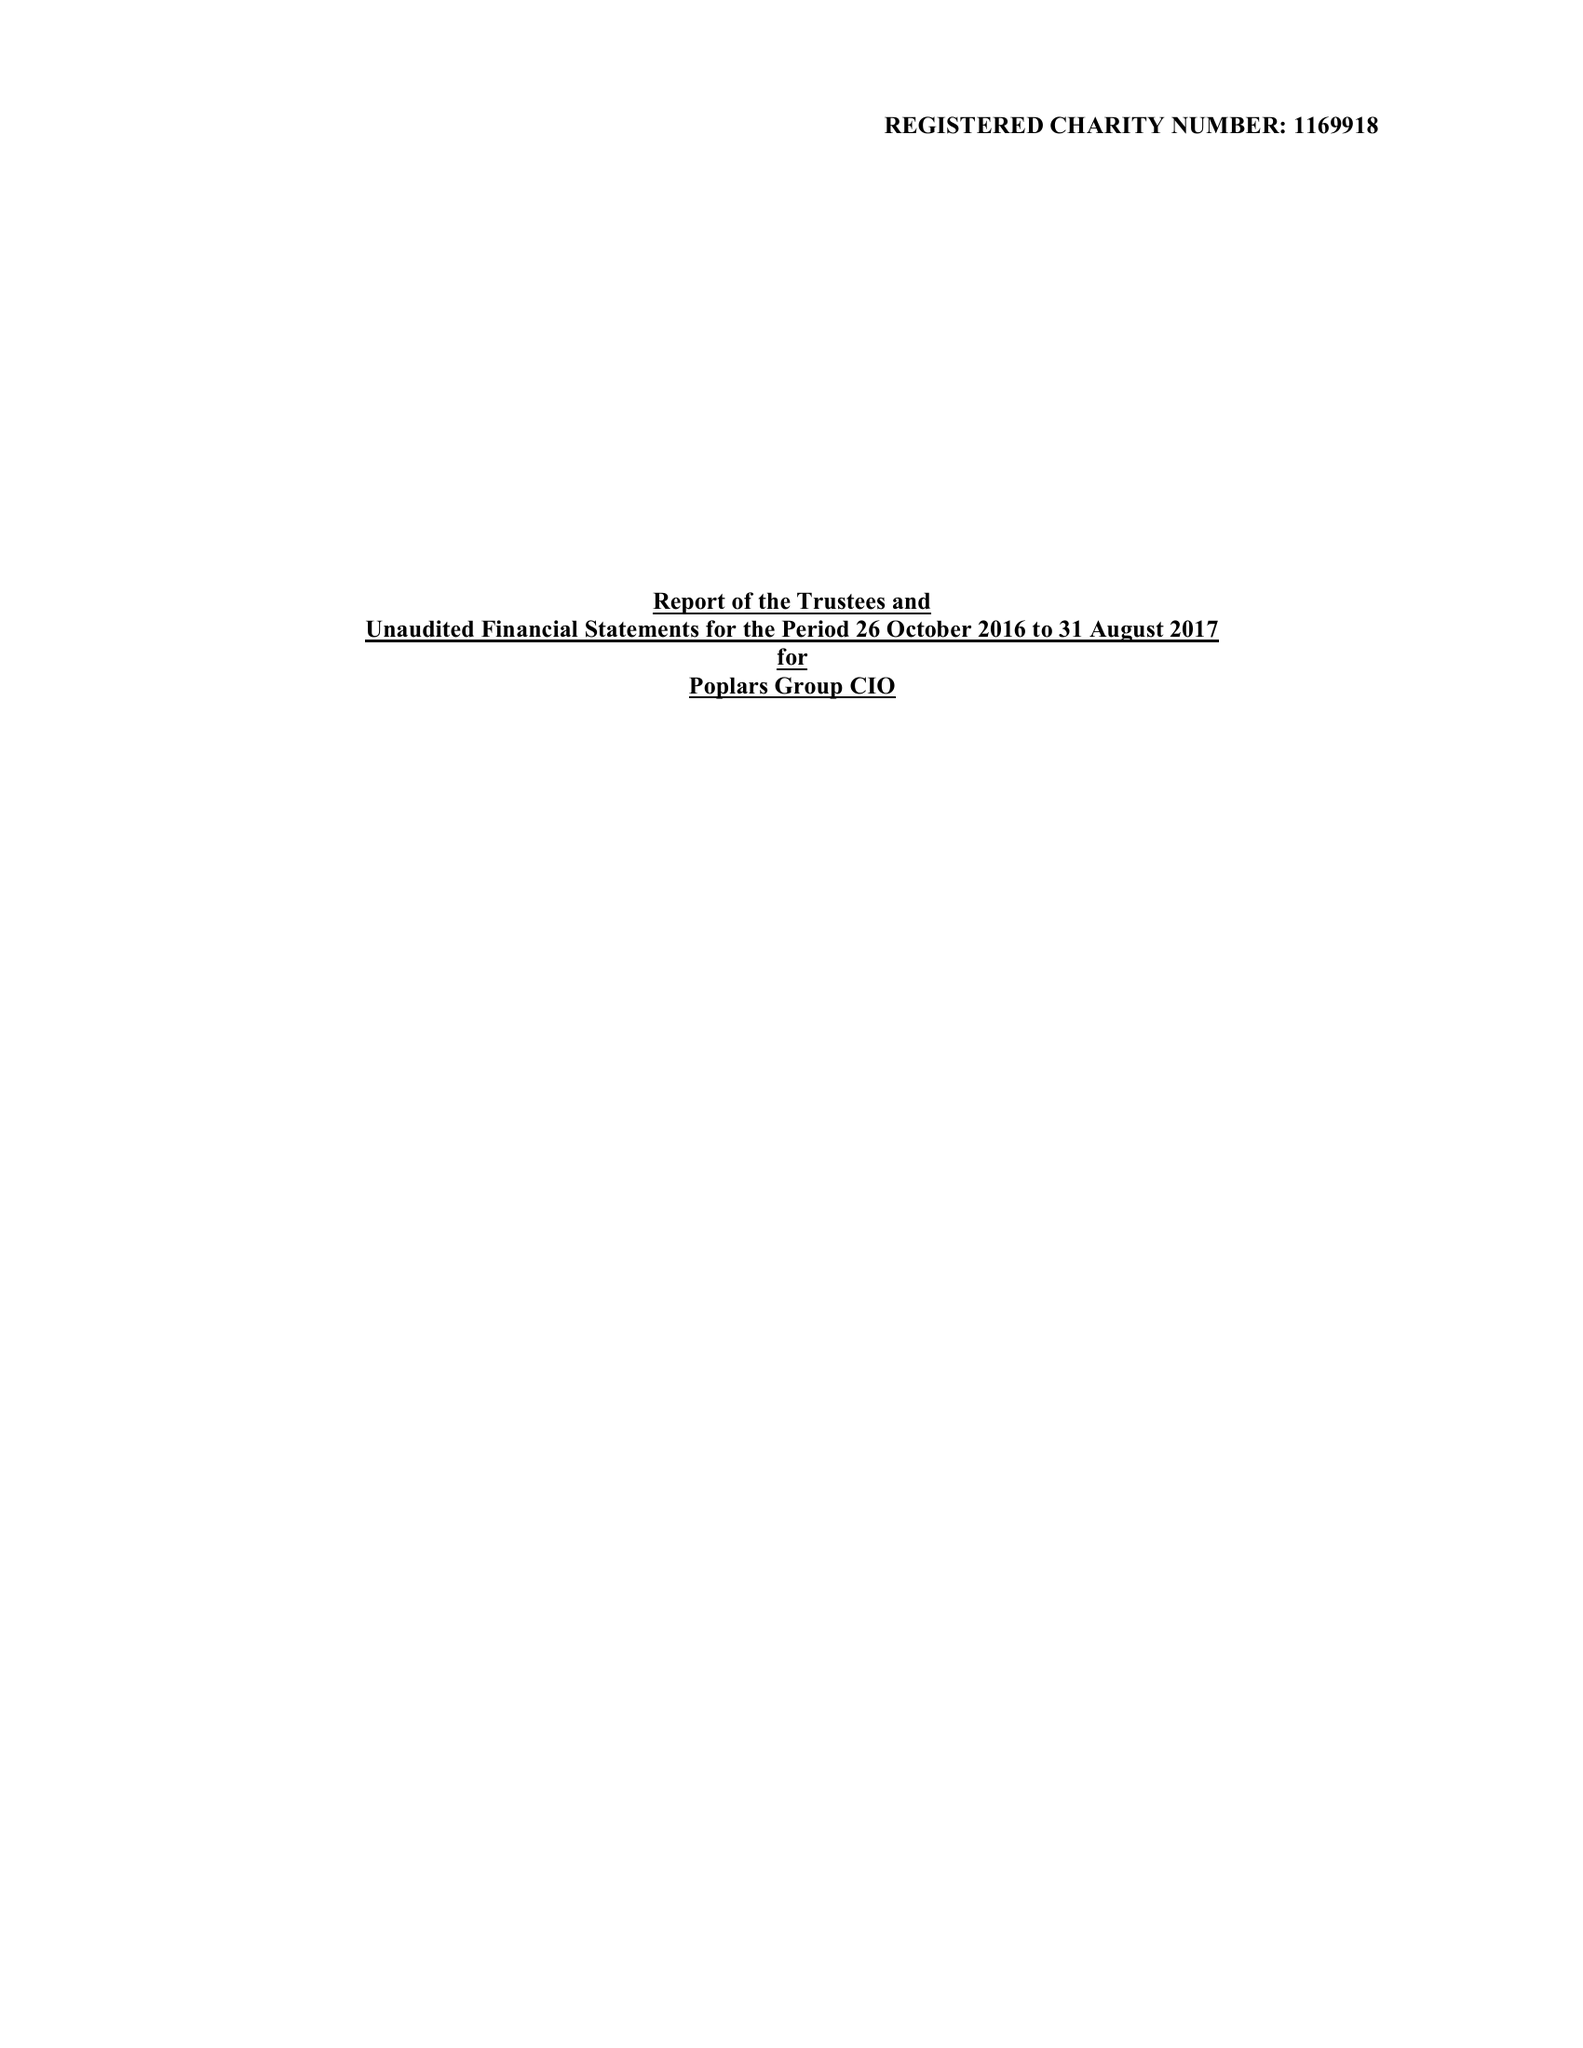What is the value for the charity_name?
Answer the question using a single word or phrase. Poplars Group 